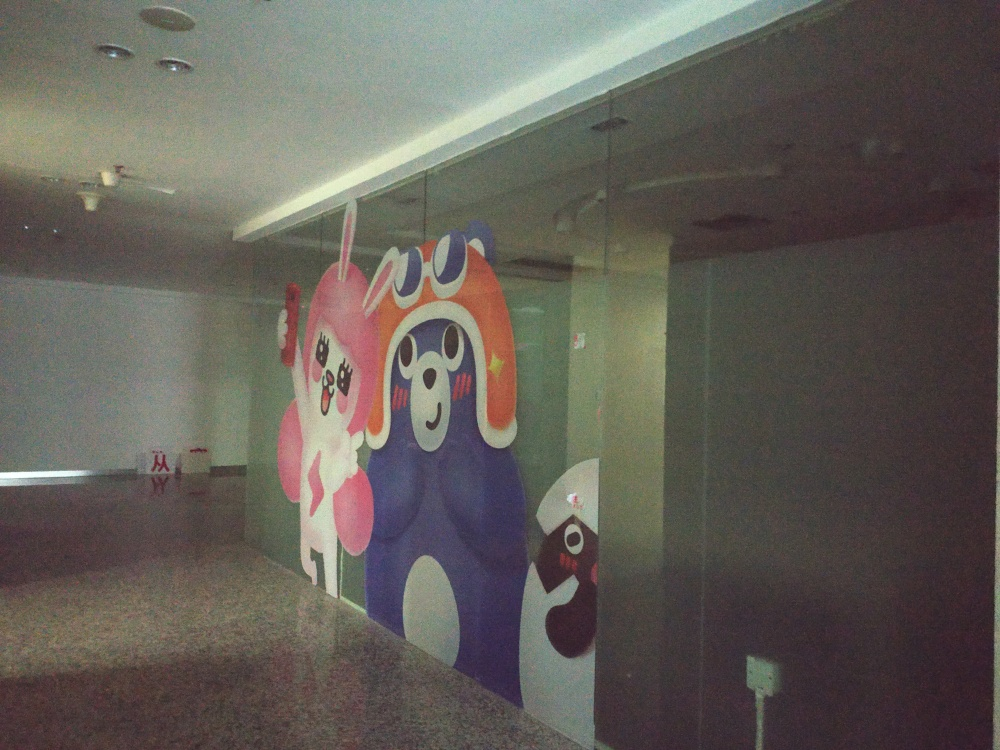Can you tell me more about the setting where this mural is located? The mural is located in an indoor space that appears to be a public or commercial area, as indicated by the spaciousness and the presence of ceiling lights and glass partitions. The setting seems to have a modern architectural style with a minimalist decor, which allows the colorful mural to stand out as a striking visual element in the environment. Does this setting influence the way we interpret the mural? Yes, the setting of a mural can influence how it's interpreted. In this case, the simplicity and modernity of the surroundings may amplify the playfulness and impact of the artwork, as there is little visual competition. The mural becomes a focal point in the space, potentially invoking curiosity and engagement from those who pass by. 